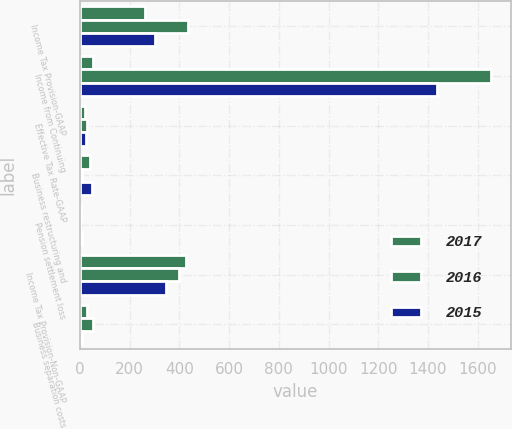Convert chart to OTSL. <chart><loc_0><loc_0><loc_500><loc_500><stacked_bar_chart><ecel><fcel>Income Tax Provision-GAAP<fcel>Income from Continuing<fcel>Effective Tax Rate-GAAP<fcel>Business restructuring and<fcel>Pension settlement loss<fcel>Income Tax Provision-Non-GAAP<fcel>Business separation costs<nl><fcel>2017<fcel>260.9<fcel>50.6<fcel>18.4<fcel>41.6<fcel>3.9<fcel>427<fcel>30.2<nl><fcel>2016<fcel>432.6<fcel>1651.7<fcel>27.8<fcel>9.8<fcel>1.8<fcel>398.9<fcel>50.6<nl><fcel>2015<fcel>300.2<fcel>1438.1<fcel>23.7<fcel>47.2<fcel>6.9<fcel>344.7<fcel>7.5<nl></chart> 